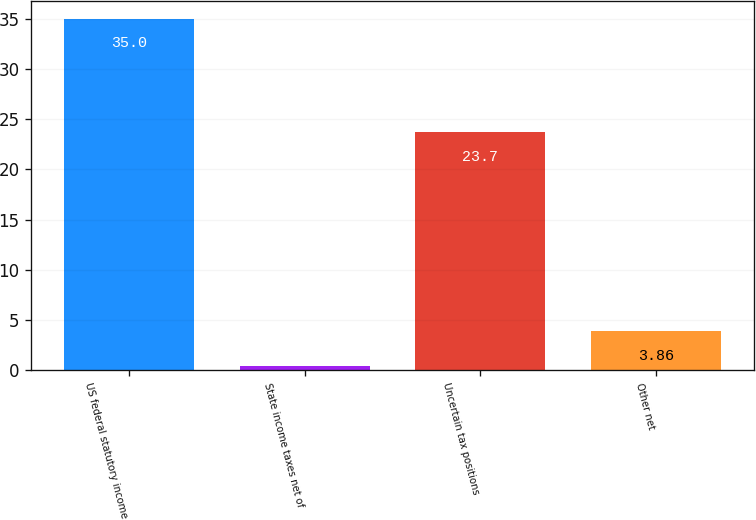Convert chart to OTSL. <chart><loc_0><loc_0><loc_500><loc_500><bar_chart><fcel>US federal statutory income<fcel>State income taxes net of<fcel>Uncertain tax positions<fcel>Other net<nl><fcel>35<fcel>0.4<fcel>23.7<fcel>3.86<nl></chart> 